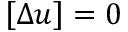Convert formula to latex. <formula><loc_0><loc_0><loc_500><loc_500>\left [ \, \left [ \Delta u \right ] \, \right ] = 0</formula> 